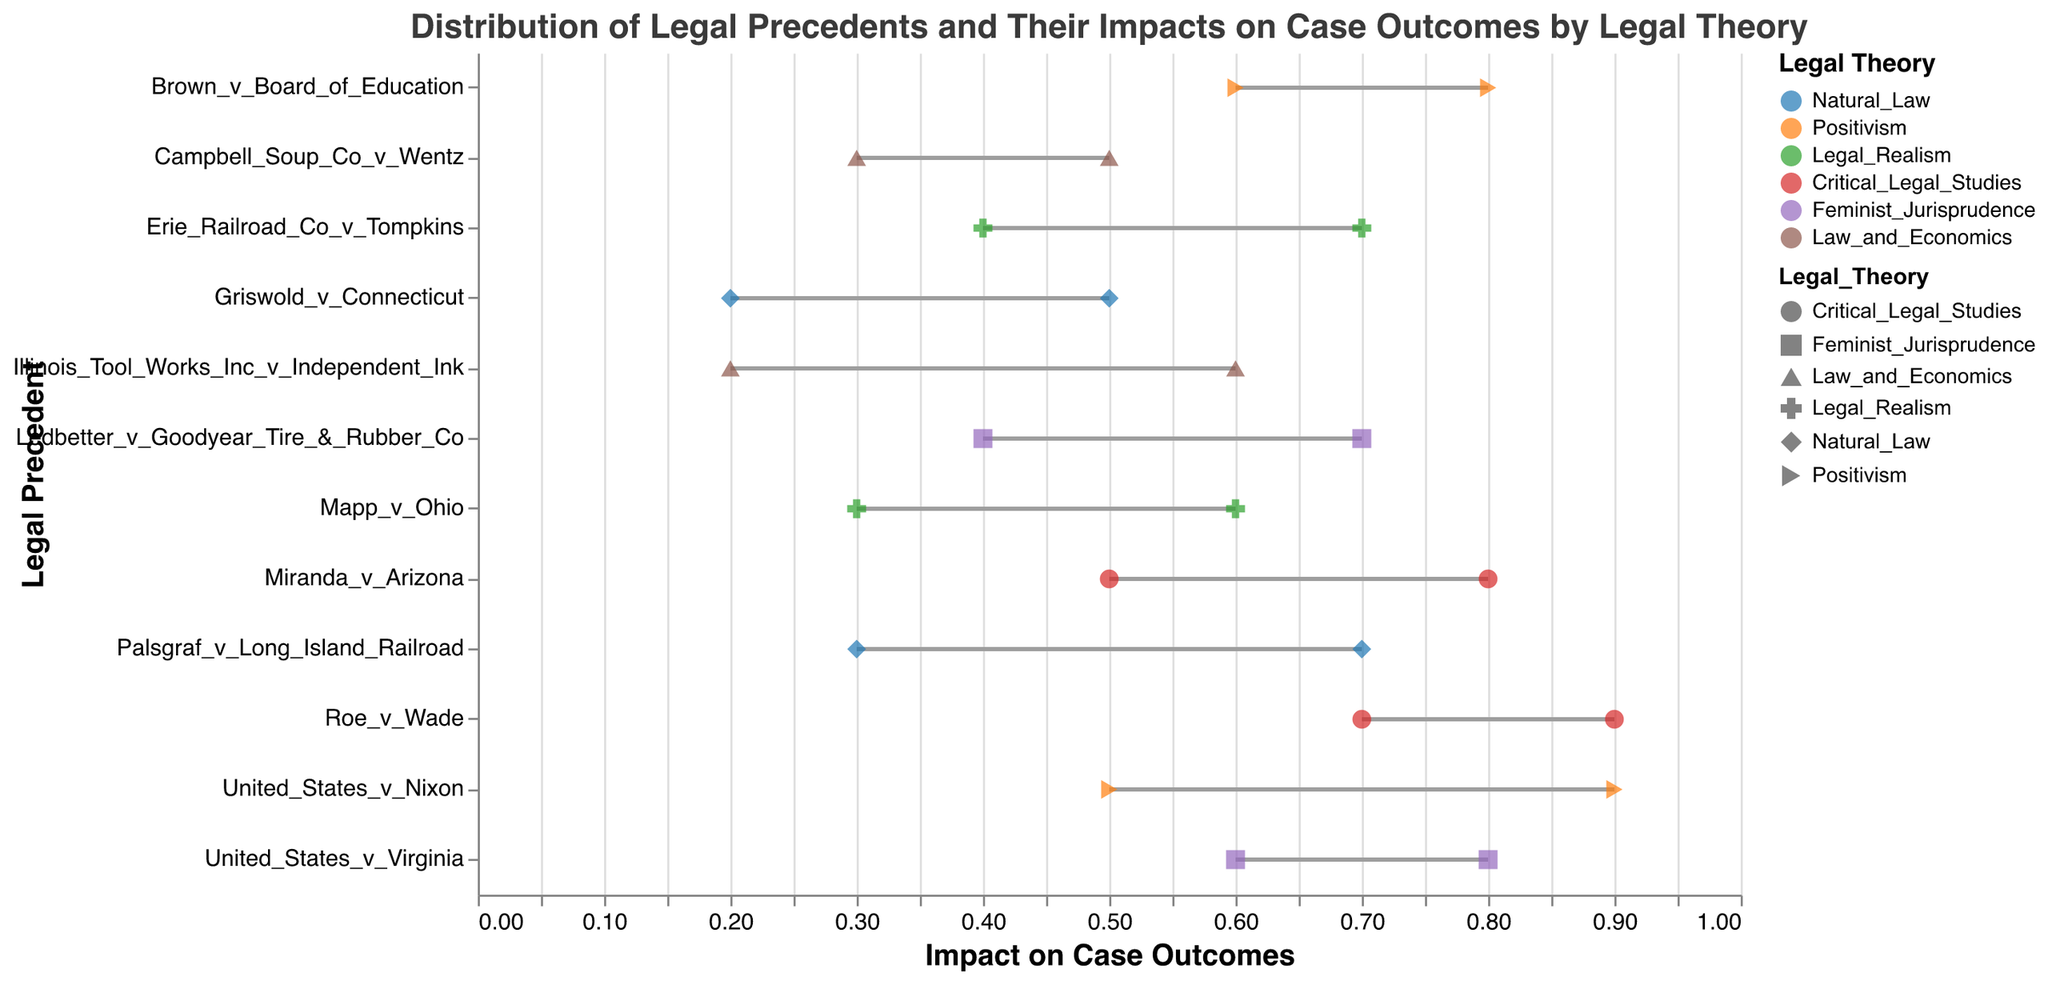What is the title of the figure? The title of the figure is typically placed at the top and it summarizes what the figure depicts. In this case, the title is "Distribution of Legal Precedents and Their Impacts on Case Outcomes by Legal Theory".
Answer: Distribution of Legal Precedents and Their Impacts on Case Outcomes by Legal Theory How many legal theories are represented in the plot? The legend in the plot lists each legal theory represented and assigns a unique color to each one. There are six different legal theories represented: Natural Law, Positivism, Legal Realism, Critical Legal Studies, Feminist Jurisprudence, and Law and Economics.
Answer: 6 Which legal precedent has the highest maximum impact on case outcomes for Positivism? To find the answer, look for the legal precedents under Positivism and compare their maximum impact values. United States v. Nixon (0.9) is the highest compared to Brown v. Board of Education (0.8).
Answer: United States v. Nixon What is the range of impact for Griswold v. Connecticut under Natural Law? The range of impact is calculated by subtracting the minimum impact from the maximum impact. For Griswold v. Connecticut, the minimum impact is 0.2 and the maximum impact is 0.5, giving a range of 0.5 - 0.2.
Answer: 0.3 How does the minimum impact of United States v. Virginia compare to that of Campbell Soup Co. v. Wentz? Look at the minimum impact points for both cases. United States v. Virginia under Feminist Jurisprudence has a minimum impact of 0.6, while Campbell Soup Co. v. Wentz under Law and Economics has a minimum impact of 0.3. 0.6 is greater than 0.3.
Answer: United States v. Virginia is greater What is the difference in maximum impact between Roe v. Wade under Critical Legal Studies and Mapp v. Ohio under Legal Realism? For Roe v. Wade, the maximum impact is 0.9, and for Mapp v. Ohio, the maximum impact is 0.6. Subtract the latter value from the former: 0.9 - 0.6.
Answer: 0.3 